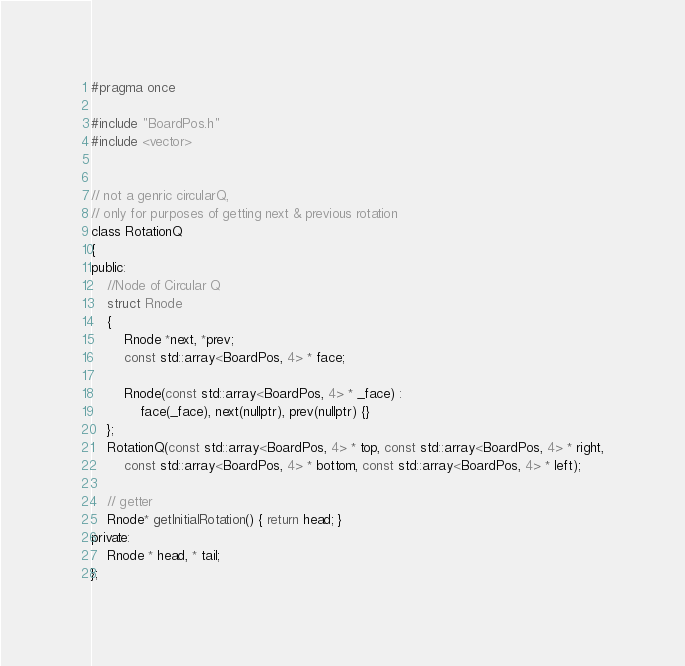<code> <loc_0><loc_0><loc_500><loc_500><_C_>#pragma once

#include "BoardPos.h"
#include <vector>


// not a genric circularQ, 
// only for purposes of getting next & previous rotation
class RotationQ
{
public:
	//Node of Circular Q
	struct Rnode
	{
		Rnode *next, *prev;
		const std::array<BoardPos, 4> * face;

		Rnode(const std::array<BoardPos, 4> * _face) :
			face(_face), next(nullptr), prev(nullptr) {}
	};
	RotationQ(const std::array<BoardPos, 4> * top, const std::array<BoardPos, 4> * right,
		const std::array<BoardPos, 4> * bottom, const std::array<BoardPos, 4> * left);

	// getter
	Rnode* getInitialRotation() { return head; }
private:
	Rnode * head, * tail;
};</code> 